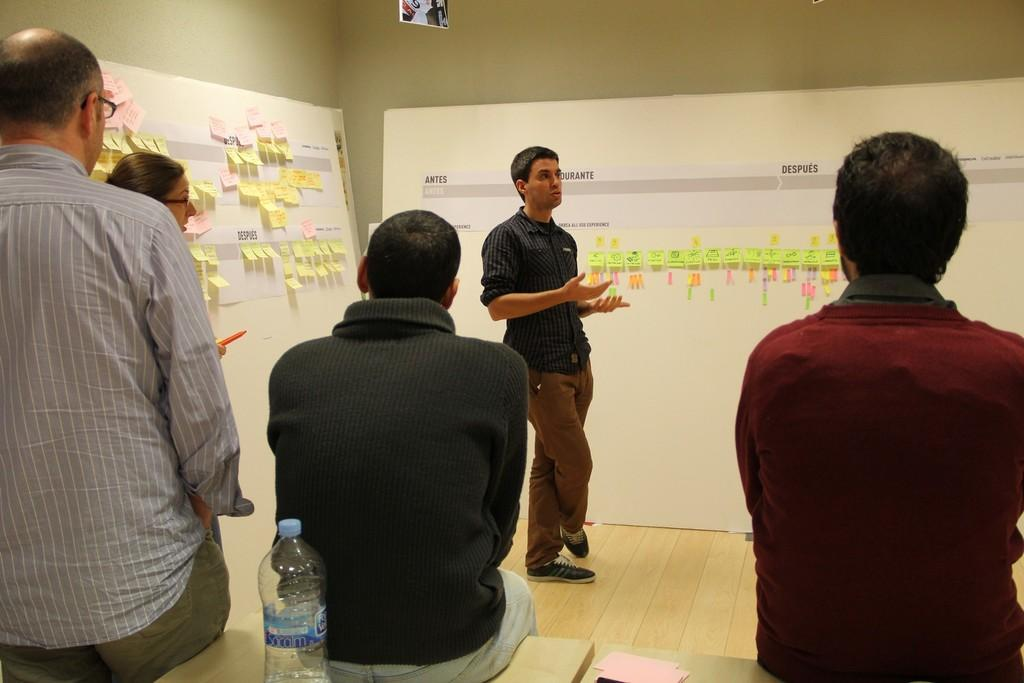How many people are in the image? There are people in the image, but the exact number is not specified. What are some of the people doing in the image? Some people are standing, and some people are sitting in the image. Where are the people located in the image? The people are on a table. What else can be seen on the table in the image? There is a water bottle on the table. What type of verse can be heard being recited by the people in the image? There is no indication in the image that the people are reciting any verse, so it cannot be determined from the picture. 